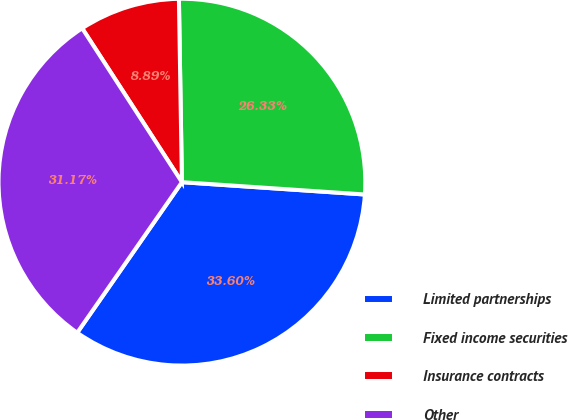<chart> <loc_0><loc_0><loc_500><loc_500><pie_chart><fcel>Limited partnerships<fcel>Fixed income securities<fcel>Insurance contracts<fcel>Other<nl><fcel>33.6%<fcel>26.33%<fcel>8.89%<fcel>31.17%<nl></chart> 